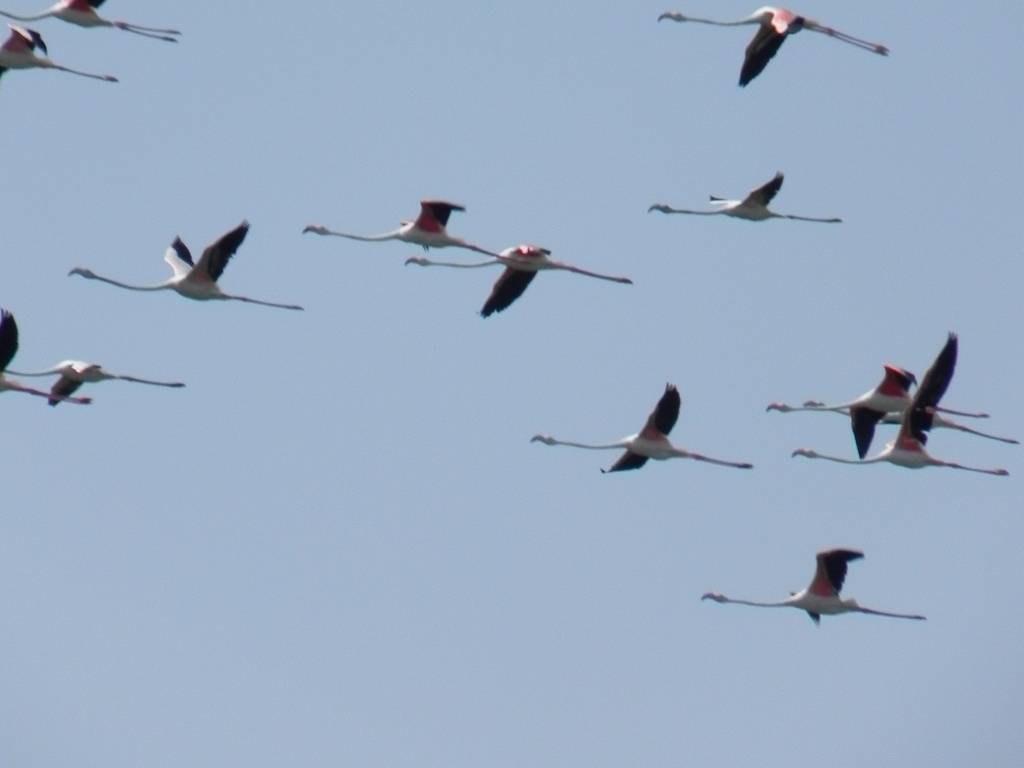What is the overall clarity of the image? A. Average B. Good C. Excellent Answer with the option's letter from the given choices directly. The overall clarity of the image can be classified as 'Average' due to the visible blurring and lack of sharp detail on the subjects, which are birds in flight. Additionally, there's noticeable image noise which detracts from the sharpness we'd expect in a 'Good' or 'Excellent' quality photo. 